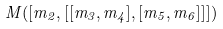Convert formula to latex. <formula><loc_0><loc_0><loc_500><loc_500>M ( [ m _ { 2 } , [ [ m _ { 3 } , m _ { 4 } ] , [ m _ { 5 } , m _ { 6 } ] ] ] )</formula> 